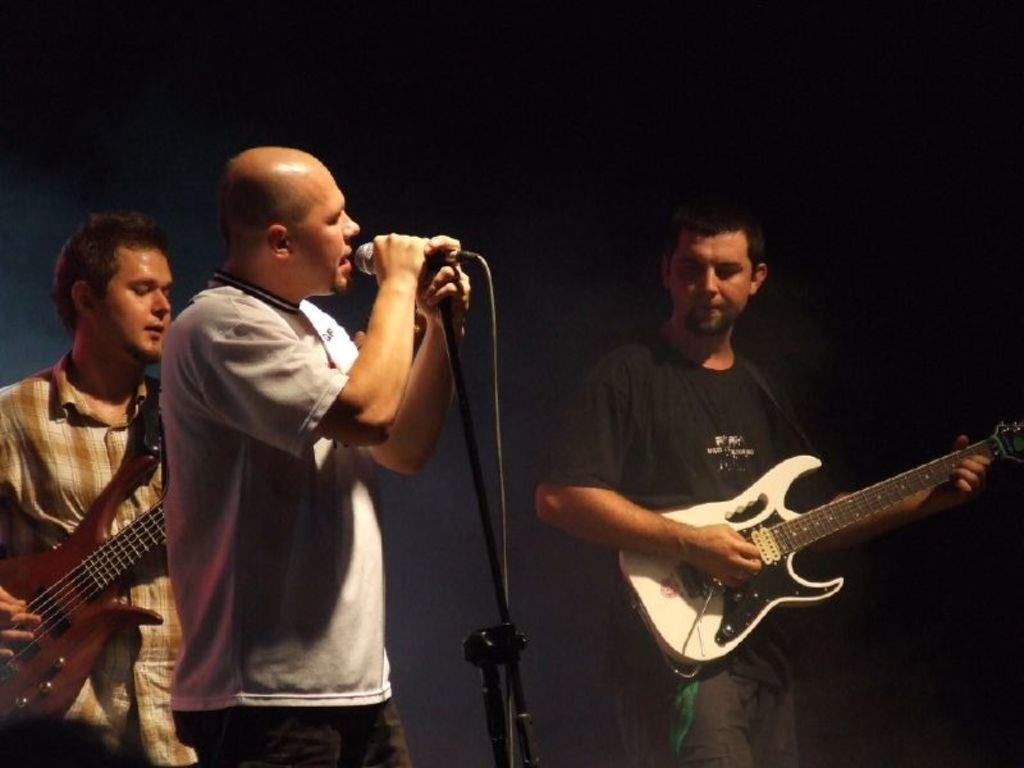How many people are in the image? There are three people in the image. What is the middle person doing? The middle person is singing. What instrument is being played by the person on the right side? The person on the right side is playing a guitar. What is the person on the left side doing? The person on the left side is also playing a guitar, holding it in their hands. What type of star can be seen in the image? There is no star visible in the image. What kind of owl is sitting on the guitarist's shoulder? There is no owl present in the image. 